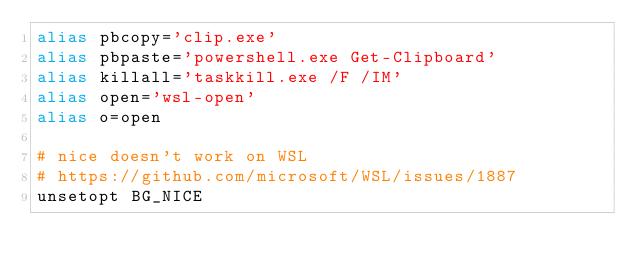<code> <loc_0><loc_0><loc_500><loc_500><_Bash_>alias pbcopy='clip.exe'
alias pbpaste='powershell.exe Get-Clipboard'
alias killall='taskkill.exe /F /IM'
alias open='wsl-open'
alias o=open

# nice doesn't work on WSL
# https://github.com/microsoft/WSL/issues/1887
unsetopt BG_NICE
</code> 